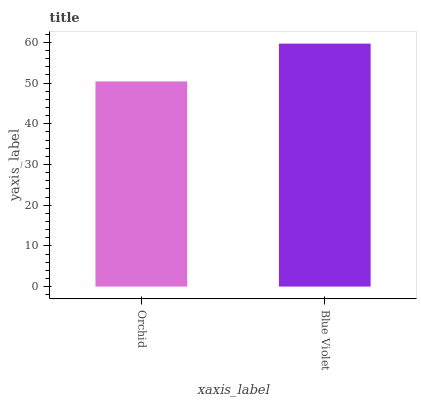Is Orchid the minimum?
Answer yes or no. Yes. Is Blue Violet the maximum?
Answer yes or no. Yes. Is Blue Violet the minimum?
Answer yes or no. No. Is Blue Violet greater than Orchid?
Answer yes or no. Yes. Is Orchid less than Blue Violet?
Answer yes or no. Yes. Is Orchid greater than Blue Violet?
Answer yes or no. No. Is Blue Violet less than Orchid?
Answer yes or no. No. Is Blue Violet the high median?
Answer yes or no. Yes. Is Orchid the low median?
Answer yes or no. Yes. Is Orchid the high median?
Answer yes or no. No. Is Blue Violet the low median?
Answer yes or no. No. 